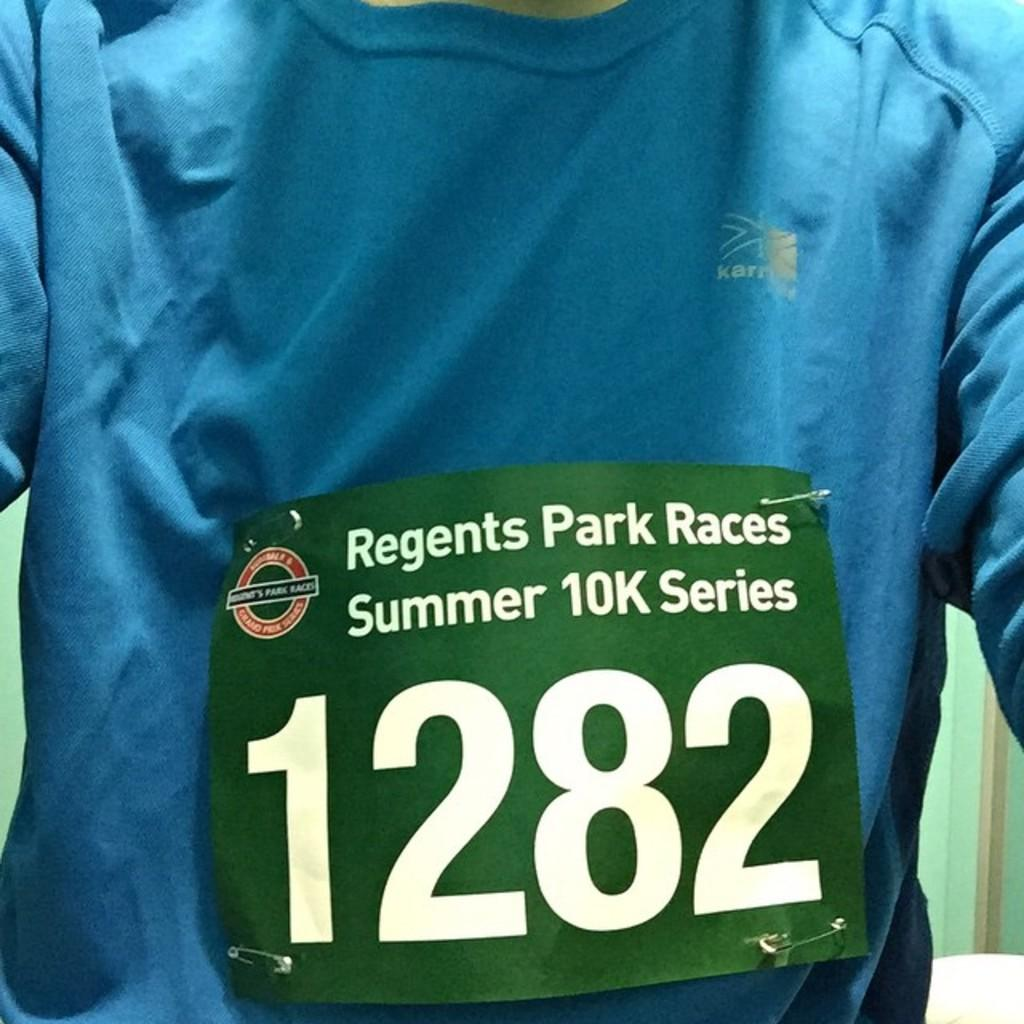Provide a one-sentence caption for the provided image. A sign in front of a shirt that says, "Regents Park Races Summer 10k Series 1282.". 